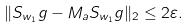<formula> <loc_0><loc_0><loc_500><loc_500>\| S _ { w _ { 1 } } g - M _ { a } S _ { w _ { 1 } } g \| _ { 2 } \leq 2 \varepsilon .</formula> 